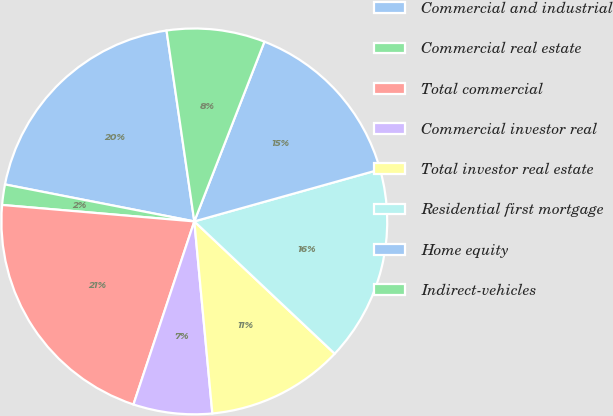<chart> <loc_0><loc_0><loc_500><loc_500><pie_chart><fcel>Commercial and industrial<fcel>Commercial real estate<fcel>Total commercial<fcel>Commercial investor real<fcel>Total investor real estate<fcel>Residential first mortgage<fcel>Home equity<fcel>Indirect-vehicles<nl><fcel>19.63%<fcel>1.71%<fcel>21.25%<fcel>6.6%<fcel>11.48%<fcel>16.37%<fcel>14.74%<fcel>8.22%<nl></chart> 